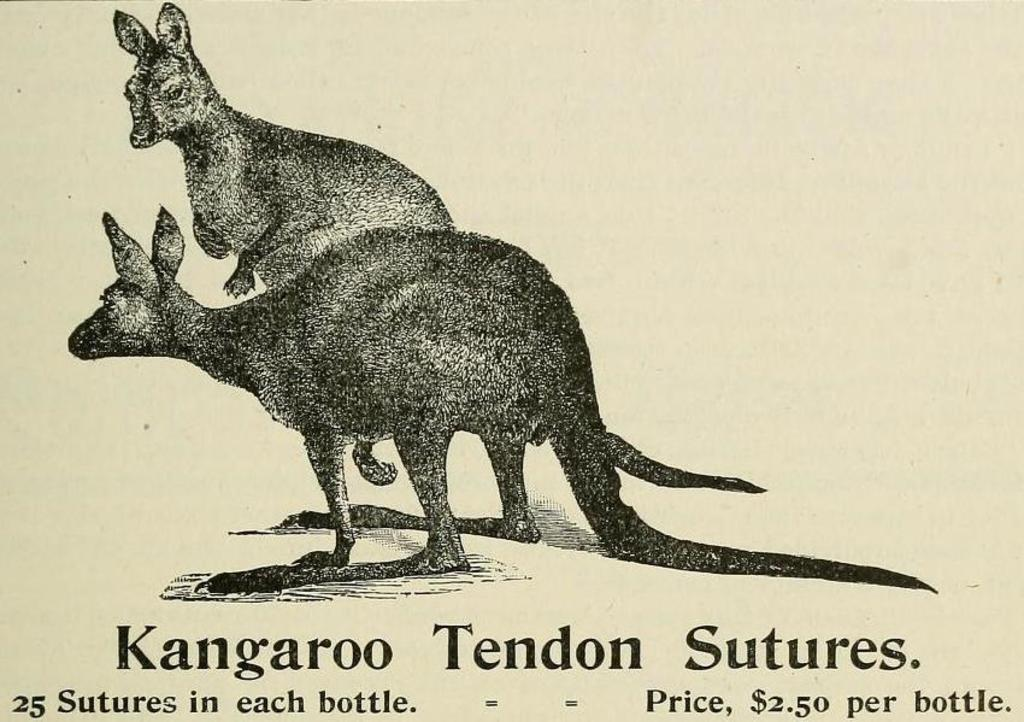What animals are depicted in the image? There is a depiction of kangaroos in the image. Are there any words or letters in the image? Yes, there is text written in the image. What type of coach can be seen in the image? There is no coach present in the image; it features a depiction of kangaroos and text. How many branches are visible in the image? There are no branches visible in the image; it only contains a depiction of kangaroos and text. 